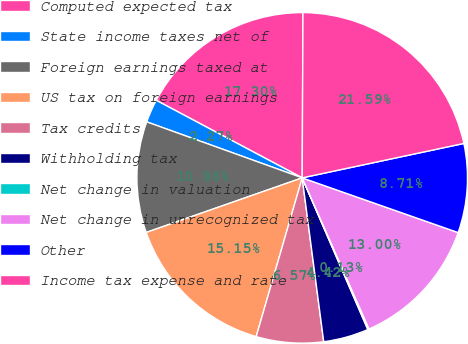<chart> <loc_0><loc_0><loc_500><loc_500><pie_chart><fcel>Computed expected tax<fcel>State income taxes net of<fcel>Foreign earnings taxed at<fcel>US tax on foreign earnings<fcel>Tax credits<fcel>Withholding tax<fcel>Net change in valuation<fcel>Net change in unrecognized tax<fcel>Other<fcel>Income tax expense and rate<nl><fcel>17.3%<fcel>2.27%<fcel>10.86%<fcel>15.15%<fcel>6.57%<fcel>4.42%<fcel>0.13%<fcel>13.0%<fcel>8.71%<fcel>21.59%<nl></chart> 